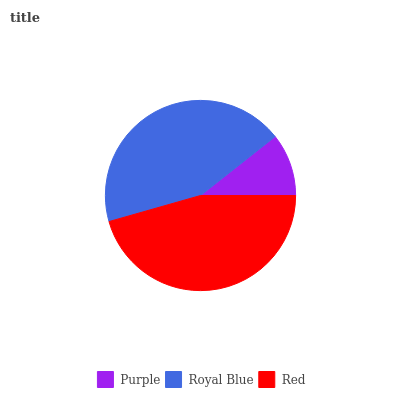Is Purple the minimum?
Answer yes or no. Yes. Is Red the maximum?
Answer yes or no. Yes. Is Royal Blue the minimum?
Answer yes or no. No. Is Royal Blue the maximum?
Answer yes or no. No. Is Royal Blue greater than Purple?
Answer yes or no. Yes. Is Purple less than Royal Blue?
Answer yes or no. Yes. Is Purple greater than Royal Blue?
Answer yes or no. No. Is Royal Blue less than Purple?
Answer yes or no. No. Is Royal Blue the high median?
Answer yes or no. Yes. Is Royal Blue the low median?
Answer yes or no. Yes. Is Purple the high median?
Answer yes or no. No. Is Purple the low median?
Answer yes or no. No. 